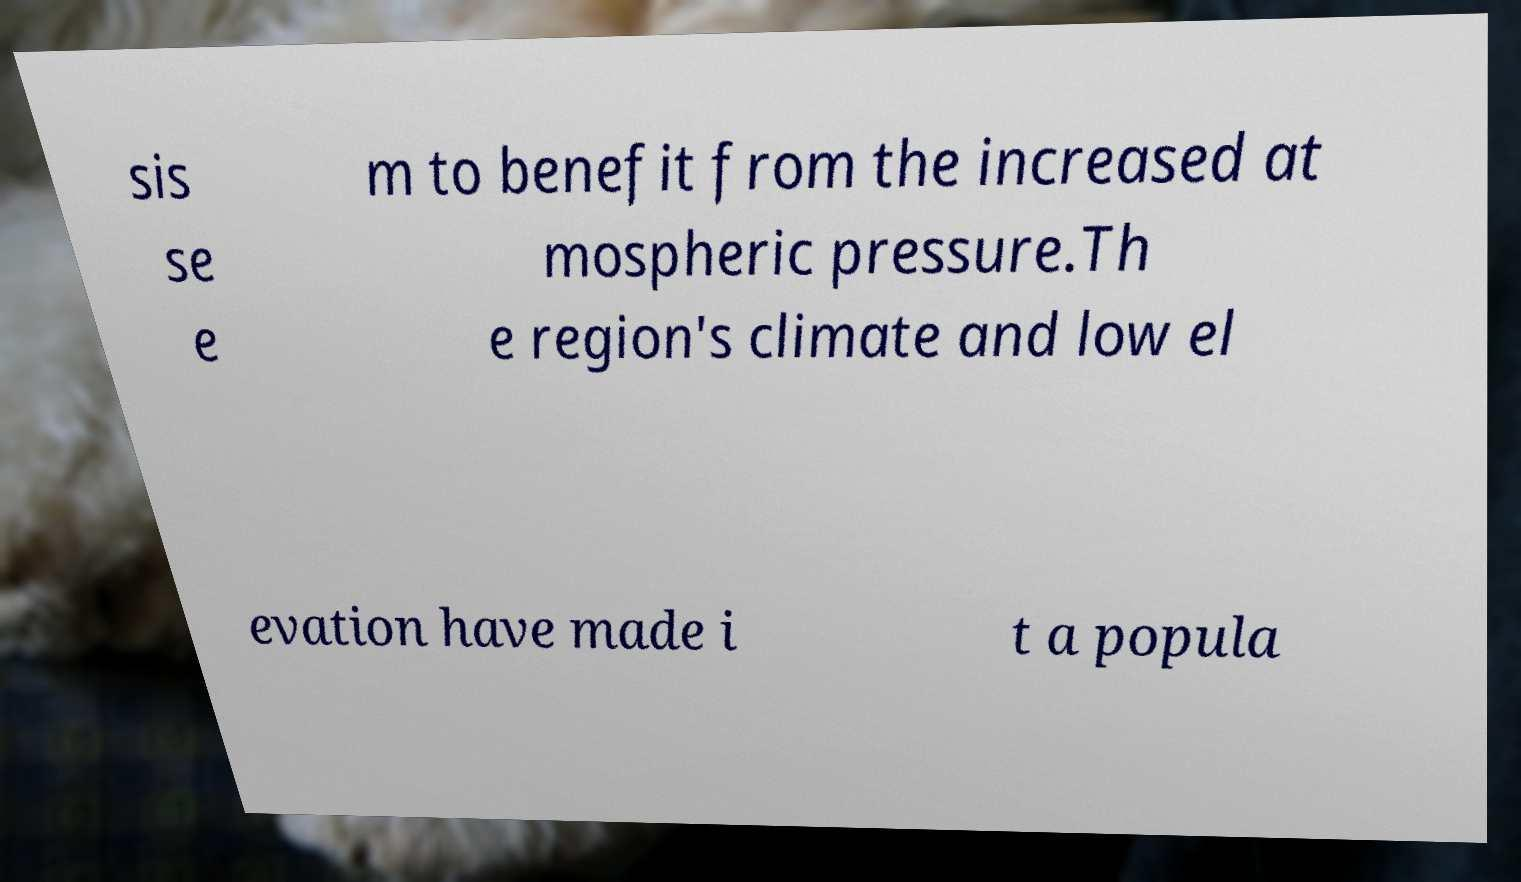Can you accurately transcribe the text from the provided image for me? sis se e m to benefit from the increased at mospheric pressure.Th e region's climate and low el evation have made i t a popula 